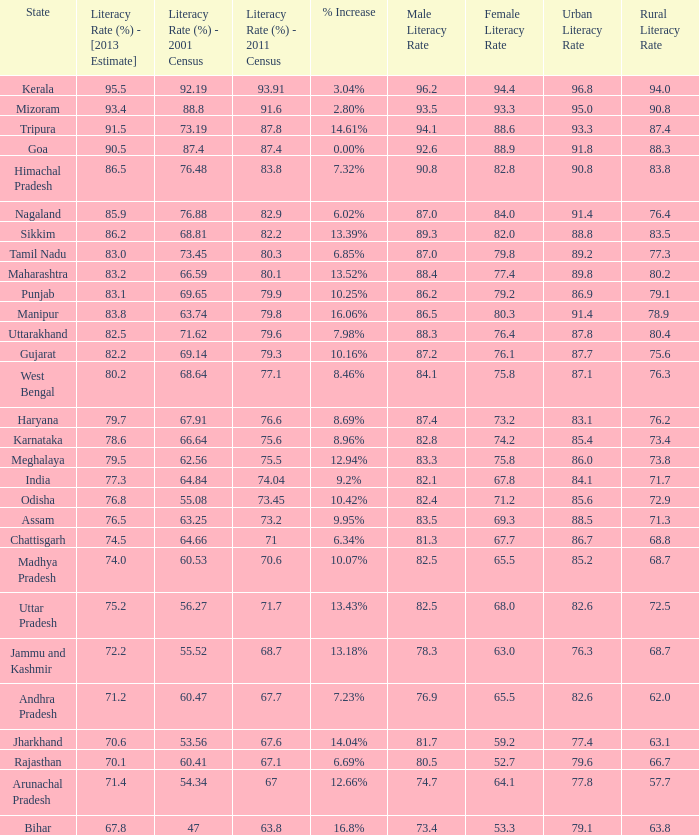What was the literacy rate published in the 2001 census for the state that saw a 12.66% increase? 54.34. 